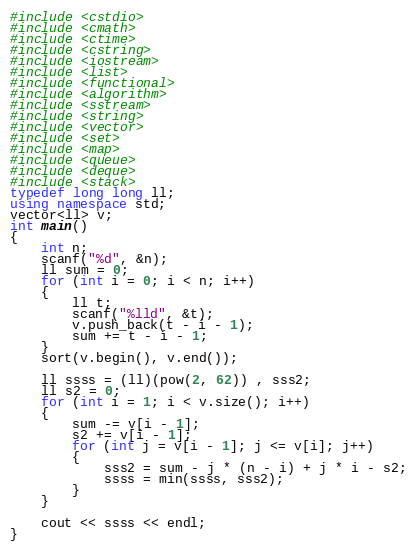Convert code to text. <code><loc_0><loc_0><loc_500><loc_500><_C++_>#include <cstdio>
#include <cmath>
#include <ctime>
#include <cstring>
#include <iostream>
#include <list>
#include <functional>
#include <algorithm>
#include <sstream>
#include <string>
#include <vector>
#include <set>
#include <map>
#include <queue>
#include <deque>
#include <stack>
typedef long long ll;
using namespace std;
vector<ll> v;
int main()
{
	int n;
	scanf("%d", &n);
	ll sum = 0;
	for (int i = 0; i < n; i++)
	{
		ll t;
		scanf("%lld", &t);
		v.push_back(t - i - 1);
		sum += t - i - 1;
	}
	sort(v.begin(), v.end());

	ll ssss = (ll)(pow(2, 62)) , sss2;
	ll s2 = 0;
	for (int i = 1; i < v.size(); i++)
	{
		sum -= v[i - 1];
		s2 += v[i - 1];
		for (int j = v[i - 1]; j <= v[i]; j++)
		{
			sss2 = sum - j * (n - i) + j * i - s2;
			ssss = min(ssss, sss2);
		}
	}

	cout << ssss << endl;
}</code> 